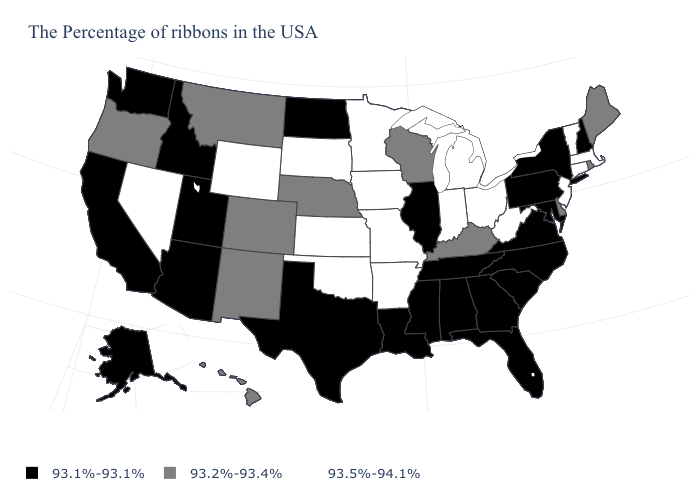What is the value of Alaska?
Write a very short answer. 93.1%-93.1%. What is the value of North Carolina?
Quick response, please. 93.1%-93.1%. What is the value of Idaho?
Keep it brief. 93.1%-93.1%. Does Utah have a higher value than South Dakota?
Answer briefly. No. What is the value of Oklahoma?
Quick response, please. 93.5%-94.1%. Which states have the lowest value in the Northeast?
Write a very short answer. New Hampshire, New York, Pennsylvania. Which states have the lowest value in the South?
Be succinct. Maryland, Virginia, North Carolina, South Carolina, Florida, Georgia, Alabama, Tennessee, Mississippi, Louisiana, Texas. What is the value of Wyoming?
Keep it brief. 93.5%-94.1%. What is the value of Mississippi?
Write a very short answer. 93.1%-93.1%. Does the map have missing data?
Keep it brief. No. Among the states that border Missouri , does Iowa have the highest value?
Give a very brief answer. Yes. What is the lowest value in the West?
Give a very brief answer. 93.1%-93.1%. Does Utah have the lowest value in the USA?
Write a very short answer. Yes. Name the states that have a value in the range 93.2%-93.4%?
Answer briefly. Maine, Rhode Island, Delaware, Kentucky, Wisconsin, Nebraska, Colorado, New Mexico, Montana, Oregon, Hawaii. What is the value of Iowa?
Answer briefly. 93.5%-94.1%. 